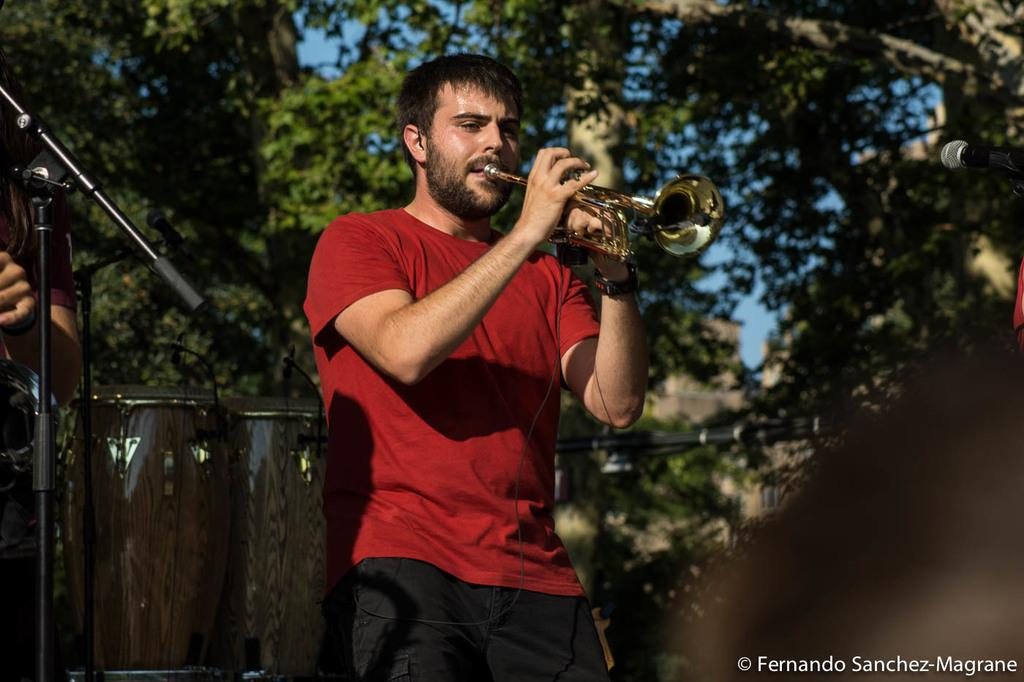What is the man in the image doing? The man in the image is playing a trombone. What else can be seen in the image besides the man playing the trombone? There is a band and a mic stand in the image. What is visible in the background of the image? There are trees in the background of the image. How does the man in the image provide comfort to the trees in the background? The man in the image is not providing comfort to the trees in the background; he is playing a trombone as part of a band. 